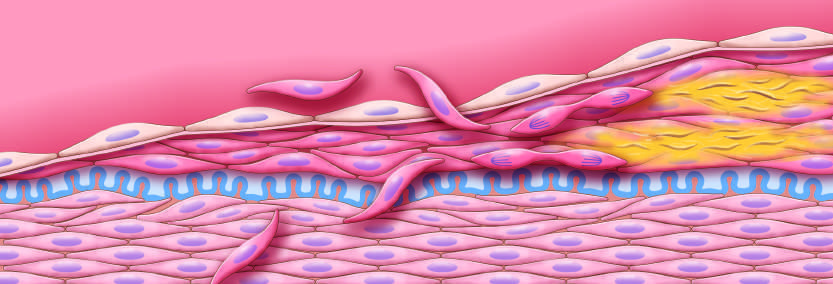did nuclear pleomorphism emphasize intimal smooth muscle cell migration and proliferation associated with extracellular matrix synthesis?
Answer the question using a single word or phrase. No 